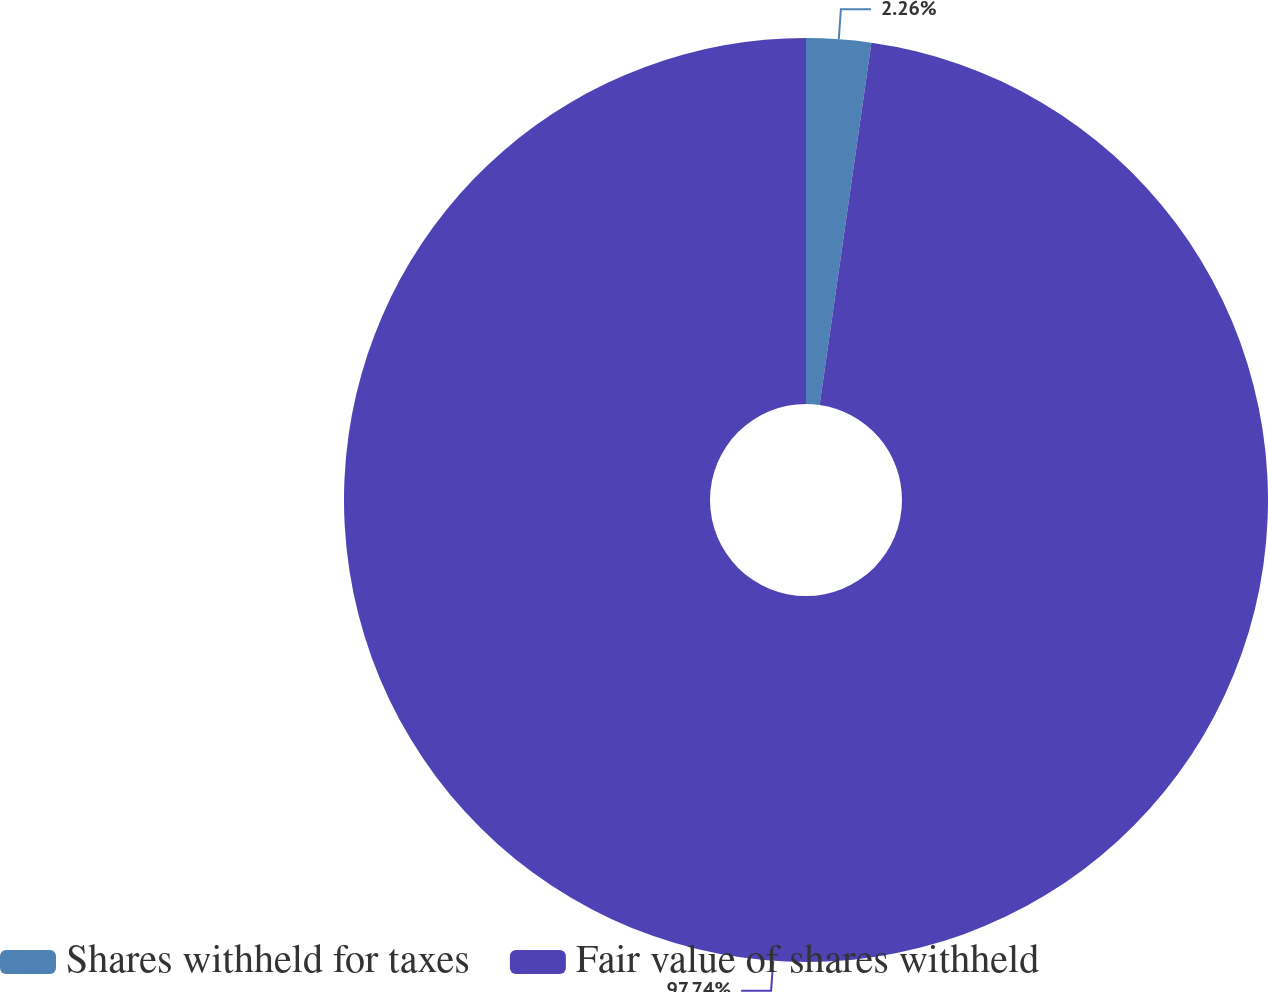<chart> <loc_0><loc_0><loc_500><loc_500><pie_chart><fcel>Shares withheld for taxes<fcel>Fair value of shares withheld<nl><fcel>2.26%<fcel>97.74%<nl></chart> 